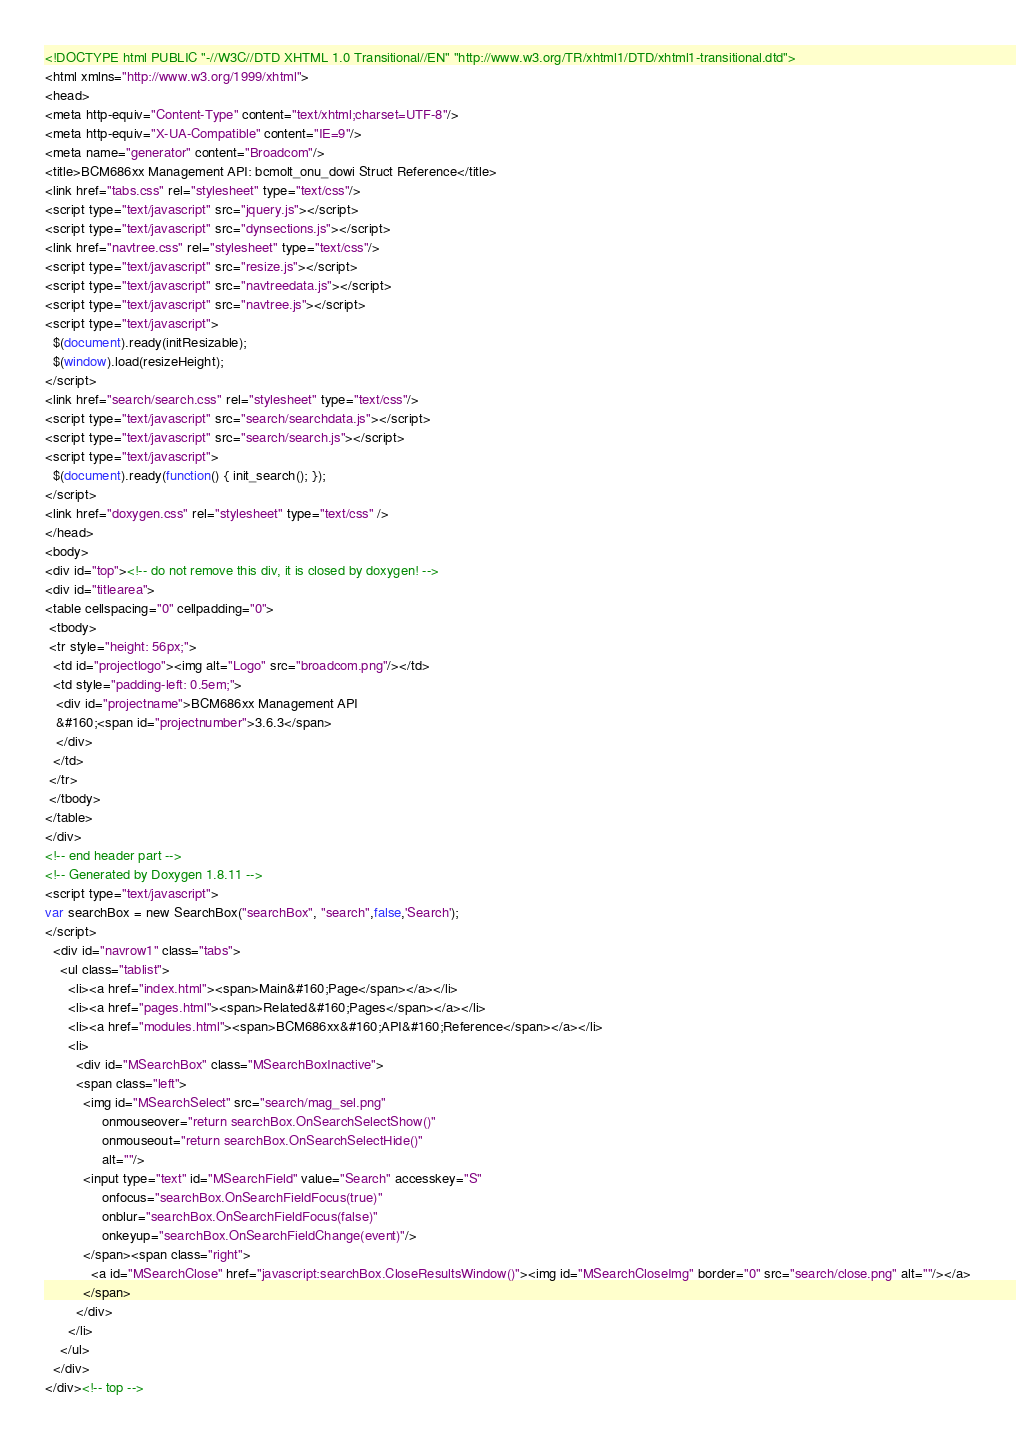Convert code to text. <code><loc_0><loc_0><loc_500><loc_500><_HTML_><!DOCTYPE html PUBLIC "-//W3C//DTD XHTML 1.0 Transitional//EN" "http://www.w3.org/TR/xhtml1/DTD/xhtml1-transitional.dtd">
<html xmlns="http://www.w3.org/1999/xhtml">
<head>
<meta http-equiv="Content-Type" content="text/xhtml;charset=UTF-8"/>
<meta http-equiv="X-UA-Compatible" content="IE=9"/>
<meta name="generator" content="Broadcom"/>
<title>BCM686xx Management API: bcmolt_onu_dowi Struct Reference</title>
<link href="tabs.css" rel="stylesheet" type="text/css"/>
<script type="text/javascript" src="jquery.js"></script>
<script type="text/javascript" src="dynsections.js"></script>
<link href="navtree.css" rel="stylesheet" type="text/css"/>
<script type="text/javascript" src="resize.js"></script>
<script type="text/javascript" src="navtreedata.js"></script>
<script type="text/javascript" src="navtree.js"></script>
<script type="text/javascript">
  $(document).ready(initResizable);
  $(window).load(resizeHeight);
</script>
<link href="search/search.css" rel="stylesheet" type="text/css"/>
<script type="text/javascript" src="search/searchdata.js"></script>
<script type="text/javascript" src="search/search.js"></script>
<script type="text/javascript">
  $(document).ready(function() { init_search(); });
</script>
<link href="doxygen.css" rel="stylesheet" type="text/css" />
</head>
<body>
<div id="top"><!-- do not remove this div, it is closed by doxygen! -->
<div id="titlearea">
<table cellspacing="0" cellpadding="0">
 <tbody>
 <tr style="height: 56px;">
  <td id="projectlogo"><img alt="Logo" src="broadcom.png"/></td>
  <td style="padding-left: 0.5em;">
   <div id="projectname">BCM686xx Management API
   &#160;<span id="projectnumber">3.6.3</span>
   </div>
  </td>
 </tr>
 </tbody>
</table>
</div>
<!-- end header part -->
<!-- Generated by Doxygen 1.8.11 -->
<script type="text/javascript">
var searchBox = new SearchBox("searchBox", "search",false,'Search');
</script>
  <div id="navrow1" class="tabs">
    <ul class="tablist">
      <li><a href="index.html"><span>Main&#160;Page</span></a></li>
      <li><a href="pages.html"><span>Related&#160;Pages</span></a></li>
      <li><a href="modules.html"><span>BCM686xx&#160;API&#160;Reference</span></a></li>
      <li>
        <div id="MSearchBox" class="MSearchBoxInactive">
        <span class="left">
          <img id="MSearchSelect" src="search/mag_sel.png"
               onmouseover="return searchBox.OnSearchSelectShow()"
               onmouseout="return searchBox.OnSearchSelectHide()"
               alt=""/>
          <input type="text" id="MSearchField" value="Search" accesskey="S"
               onfocus="searchBox.OnSearchFieldFocus(true)" 
               onblur="searchBox.OnSearchFieldFocus(false)" 
               onkeyup="searchBox.OnSearchFieldChange(event)"/>
          </span><span class="right">
            <a id="MSearchClose" href="javascript:searchBox.CloseResultsWindow()"><img id="MSearchCloseImg" border="0" src="search/close.png" alt=""/></a>
          </span>
        </div>
      </li>
    </ul>
  </div>
</div><!-- top --></code> 